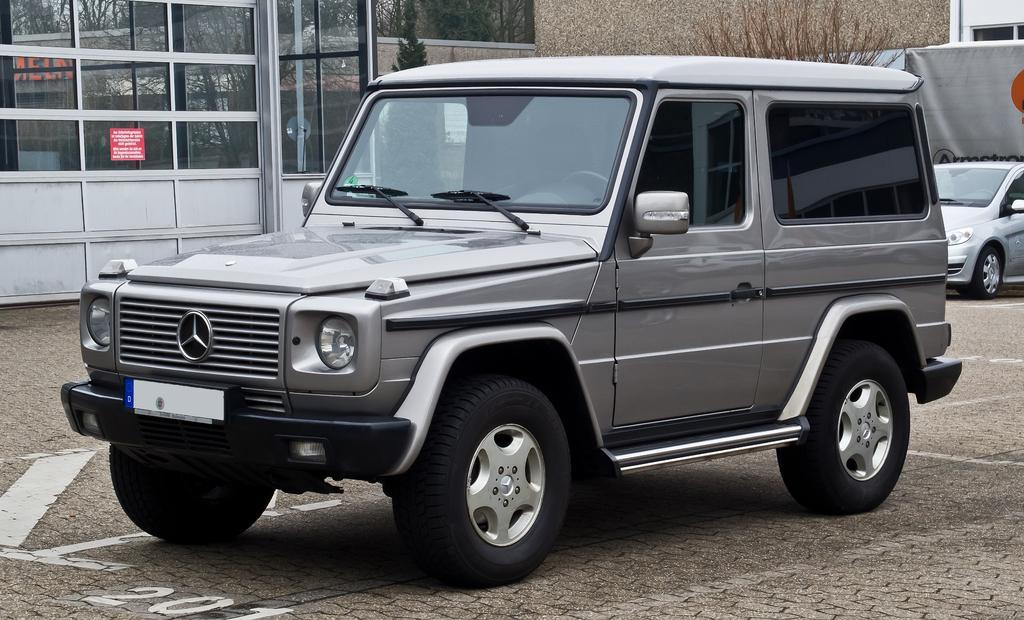Please provide a concise description of this image. In the picture there are some vehicles kept on a pavement, behind that there are some windows beside a wall. 